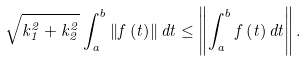<formula> <loc_0><loc_0><loc_500><loc_500>\sqrt { k _ { 1 } ^ { 2 } + k _ { 2 } ^ { 2 } } \int _ { a } ^ { b } \left \| f \left ( t \right ) \right \| d t \leq \left \| \int _ { a } ^ { b } f \left ( t \right ) d t \right \| .</formula> 